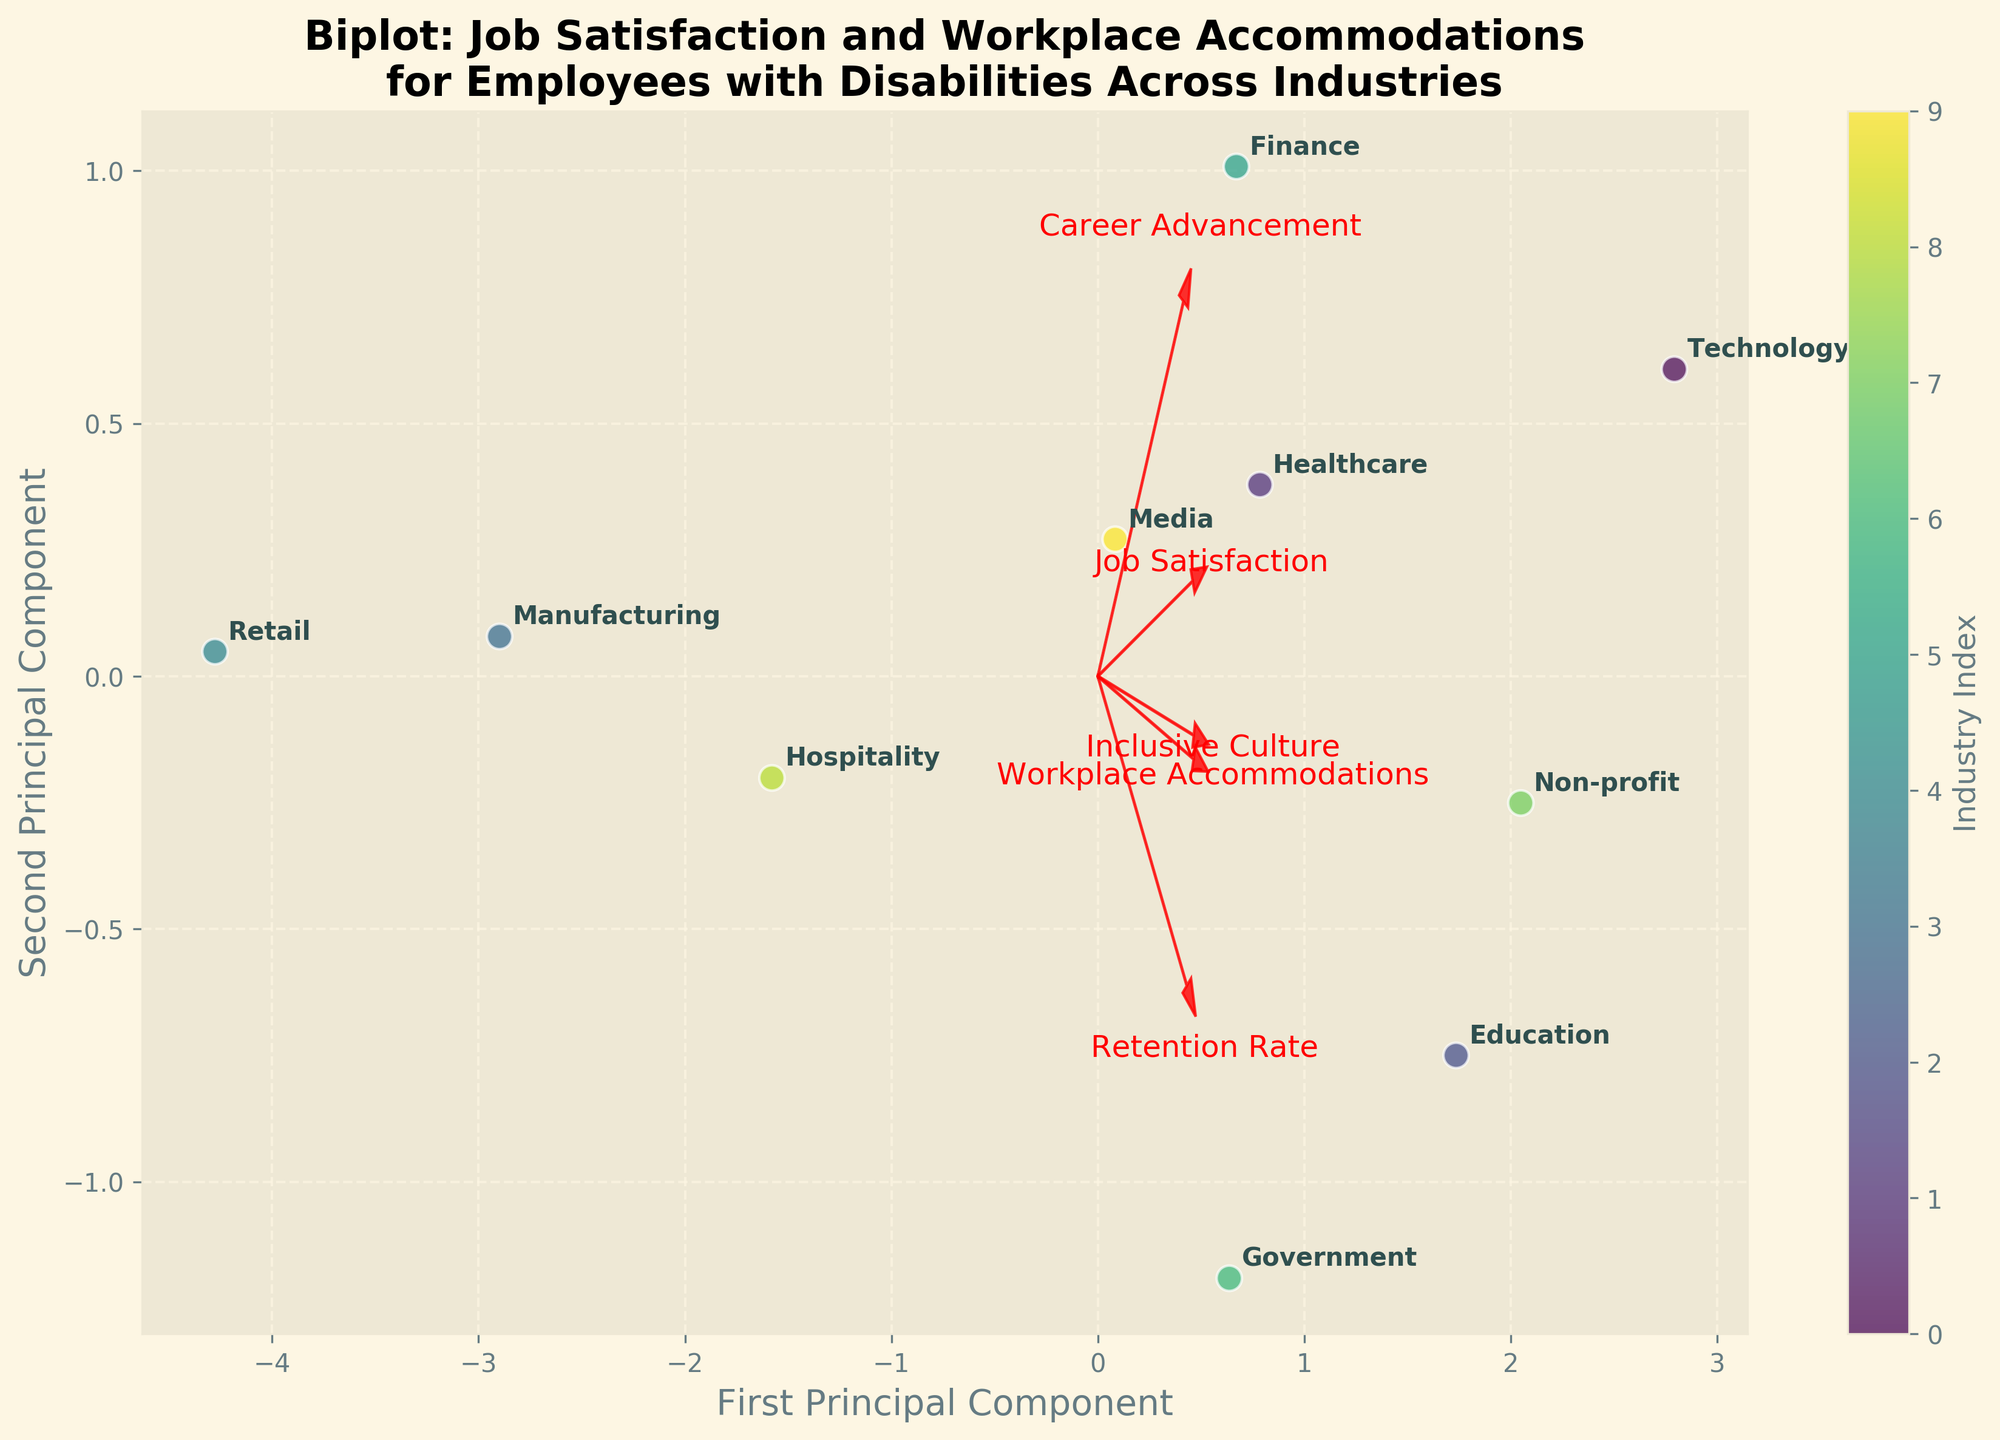What is the title of the biplot? The title of the biplot is typically located at the top of the figure in a prominent font. It gives a brief description of the figure's content.
Answer: "Biplot: Job Satisfaction and Workplace Accommodations for Employees with Disabilities Across Industries" How many industries are displayed in the biplot? We can count the number of unique labeled points in the biplot, each representing a different industry.
Answer: 10 Which industry is plotted closest to the origin (0,0)? By examining the coordinates of the plotted points, the industry closest to the origin is the one with both coordinate values closest to zero.
Answer: Education What features are represented by the vectors in the biplot? Feature vectors are typically labeled with text at their endpoints. By reading these labels, we can identify the features.
Answer: Job Satisfaction, Workplace Accommodations, Retention Rate, Career Advancement, Inclusive Culture Does the Technology industry have a higher job satisfaction score or workplace accommodations score? In a biplot, the direction and length of the vectors help us determine the relative scores. The Technology industry's position relative to these vectors will indicate which score is higher.
Answer: Workplace Accommodations Which feature vector points most positively along the first principal component? The feature vector most closely aligned in the direction of the first principal component with the largest positive value on this axis is identified by examining its orientation.
Answer: Workplace Accommodations What is the general relationship between job satisfaction and workplace accommodations among the industries? By observing the directions and proximities in which the industries align with the vectors of job satisfaction and workplace accommodations, we can infer their relationship.
Answer: Positive Correlation Which industry appears farthest in the direction of the 'Career Advancement' vector? The industry closest to the direction of the 'Career Advancement' vector can be determined by locating the point farthest along this vector.
Answer: Finance Is the "Inclusive Culture" vector more aligned with the first principal component or the second? By examining the angle between the "Inclusive Culture" vector and the principal component axes, we can judge its alignment.
Answer: First Principal Component Which industries cluster together closely in the biplot? Industries that are plotted close to each other indicate similar profiles. By visually inspecting clusters of points, we can identify these groups.
Answer: Healthcare, Finance, Media 